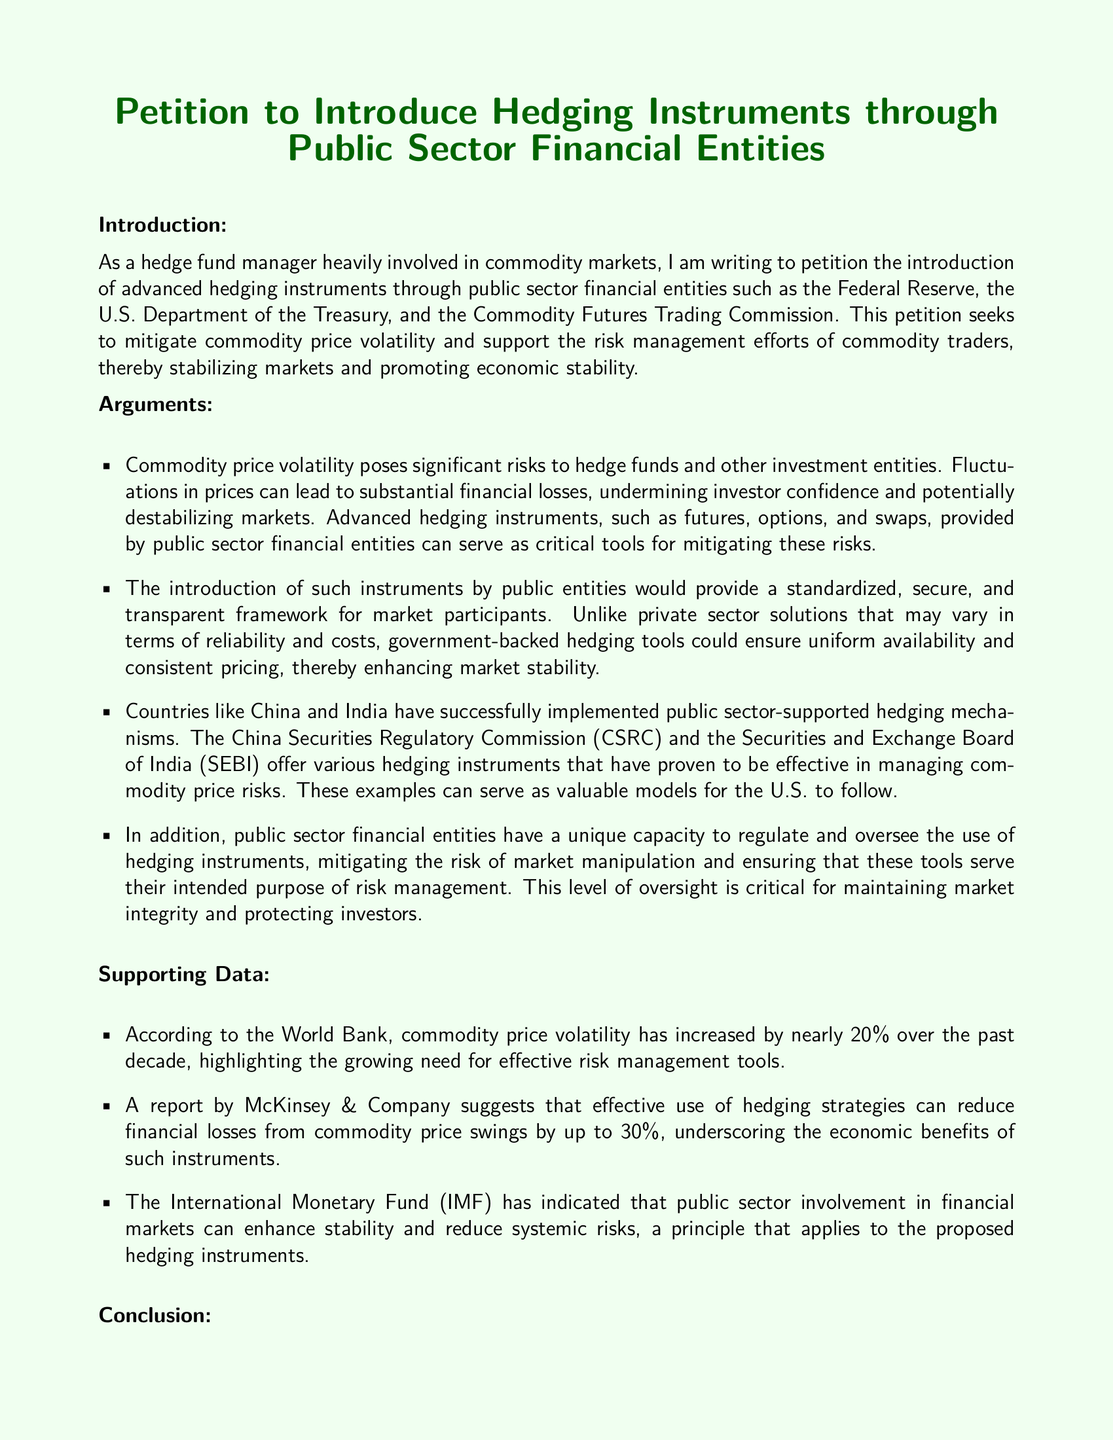What is the title of the document? The title is presented prominently at the beginning of the document.
Answer: Petition to Introduce Hedging Instruments through Public Sector Financial Entities Who is the author of the petition? The author's name is mentioned in the closing section of the document.
Answer: John Smith What types of financial instruments are proposed for introduction? The document lists specifically what hedging instruments are being petitioned for.
Answer: Futures, options, and swaps Which organization is mentioned as a model for public sector-supported hedging mechanisms? The document provides examples of countries with successful implementation of hedging mechanisms.
Answer: China By how much can effective hedging strategies reduce financial losses? The document cites a specific percentage illustrating the impact of hedging strategies.
Answer: 30% What increase in commodity price volatility does the World Bank report? The document provides a specific figure regarding the increase in volatility over a set period.
Answer: 20% Which public sector financial entities are urged to consider the petition? The petition explicitly names the entities it targets for action.
Answer: Federal Reserve, U.S. Department of the Treasury, Commodity Futures Trading Commission What is the primary purpose of the petition? The overall goal of the petition is summarized in the introductory remarks.
Answer: Mitigate commodity price volatility What does the IMF suggest about public sector involvement? The document reflects insights from the IMF regarding the effects of public sector actions in financial markets.
Answer: Enhances stability and reduces systemic risks 